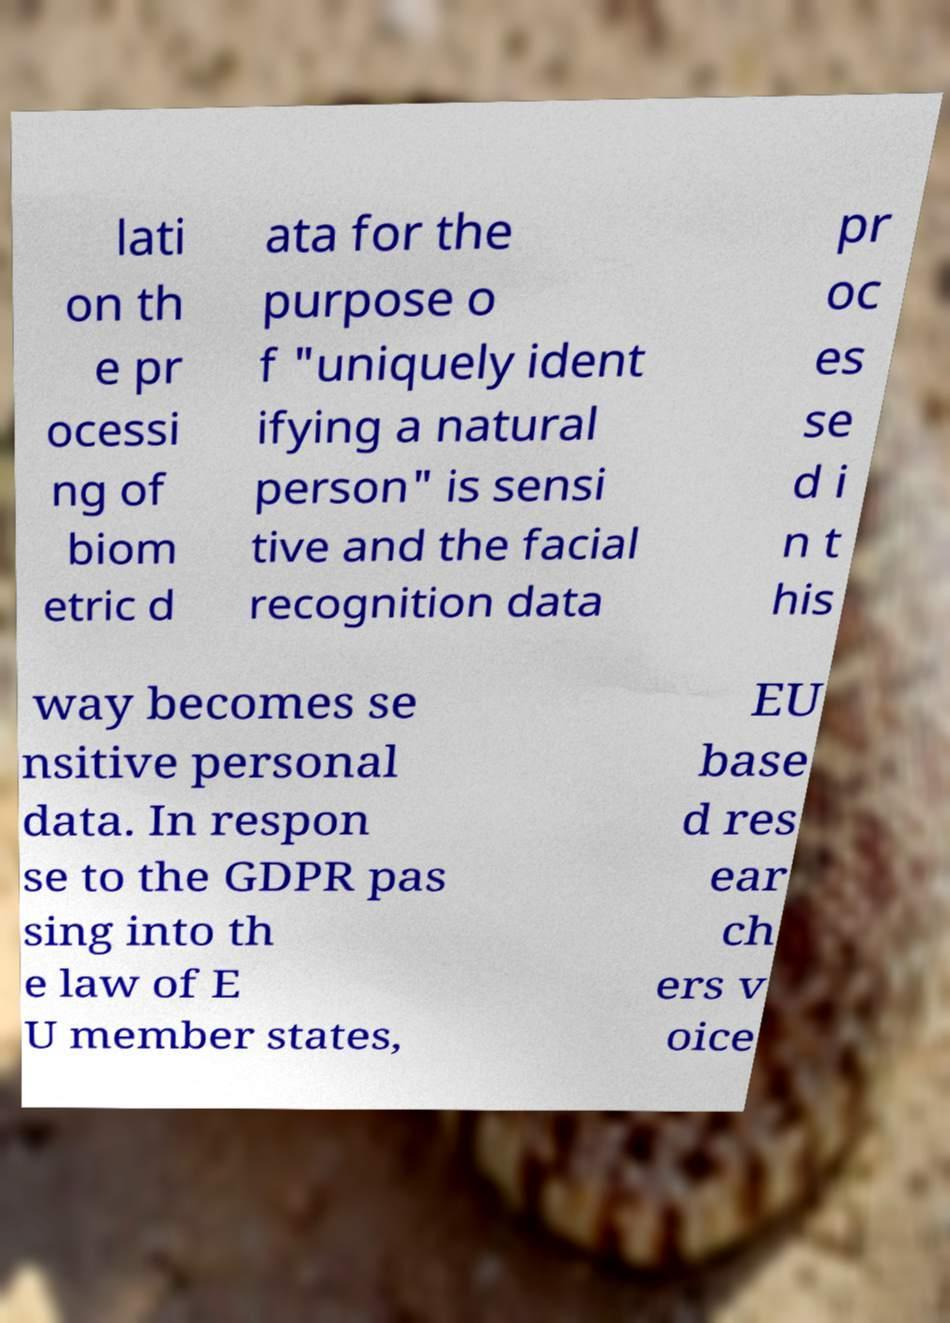I need the written content from this picture converted into text. Can you do that? lati on th e pr ocessi ng of biom etric d ata for the purpose o f "uniquely ident ifying a natural person" is sensi tive and the facial recognition data pr oc es se d i n t his way becomes se nsitive personal data. In respon se to the GDPR pas sing into th e law of E U member states, EU base d res ear ch ers v oice 